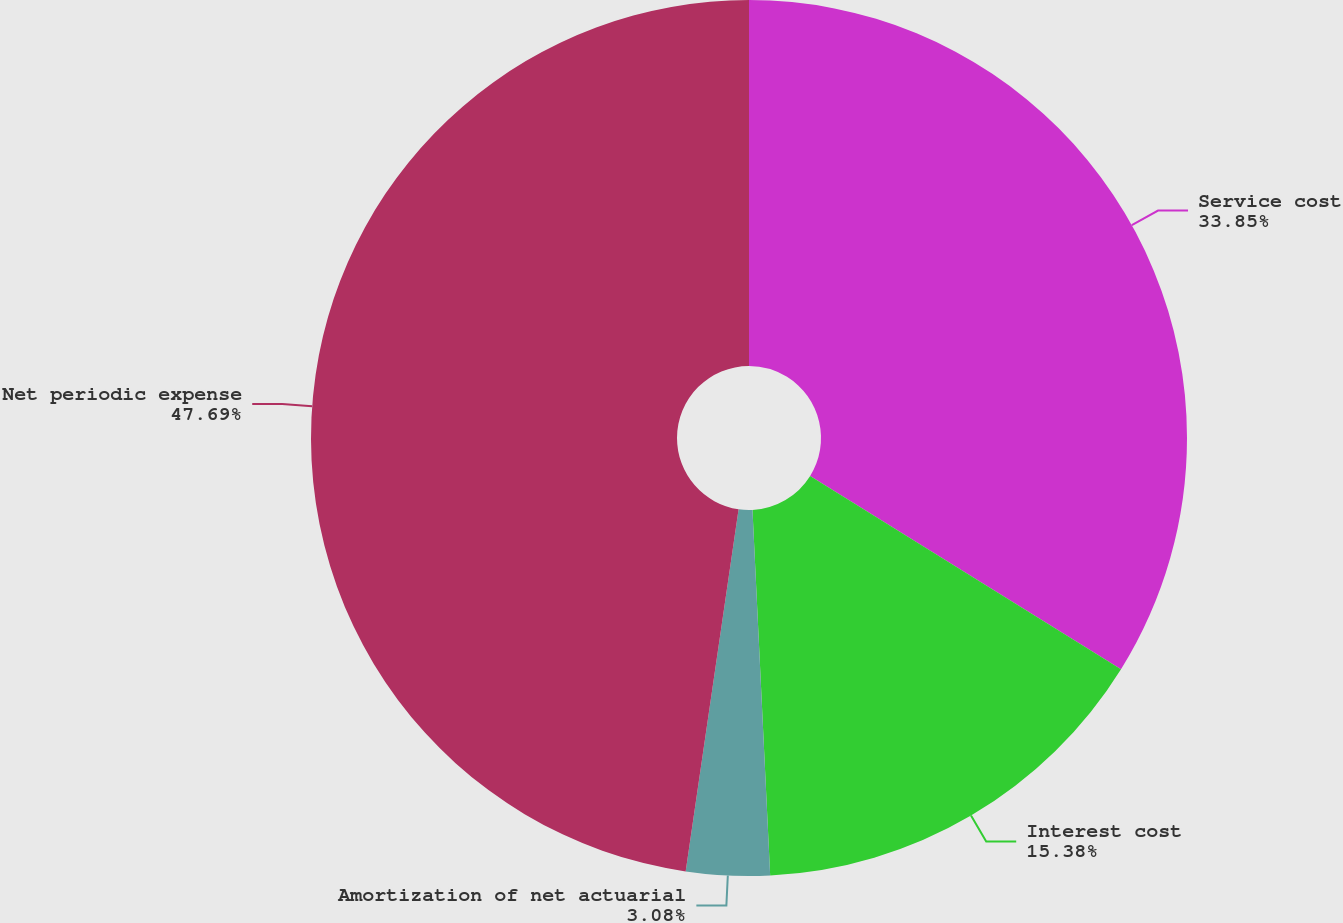Convert chart. <chart><loc_0><loc_0><loc_500><loc_500><pie_chart><fcel>Service cost<fcel>Interest cost<fcel>Amortization of net actuarial<fcel>Net periodic expense<nl><fcel>33.85%<fcel>15.38%<fcel>3.08%<fcel>47.69%<nl></chart> 